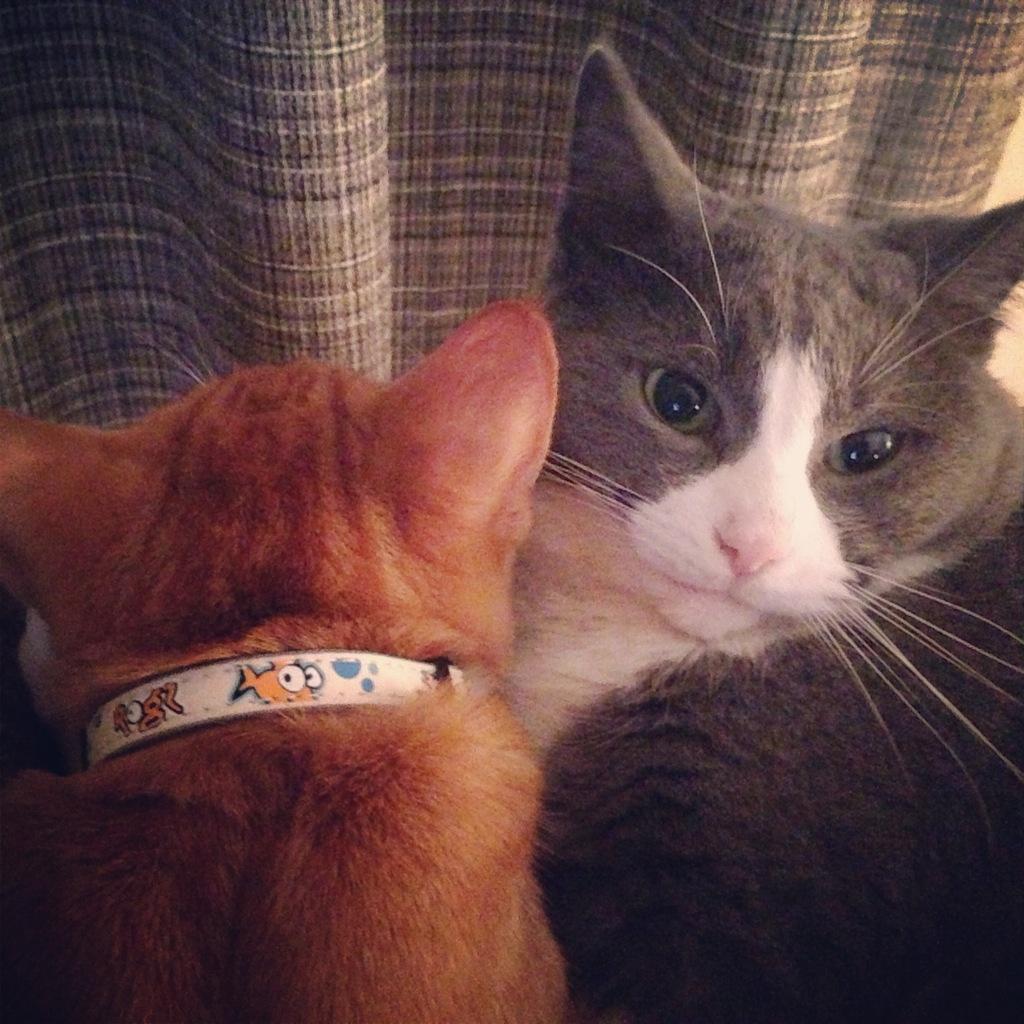Describe this image in one or two sentences. In this picture there are cats. At the top there is a cloth. 